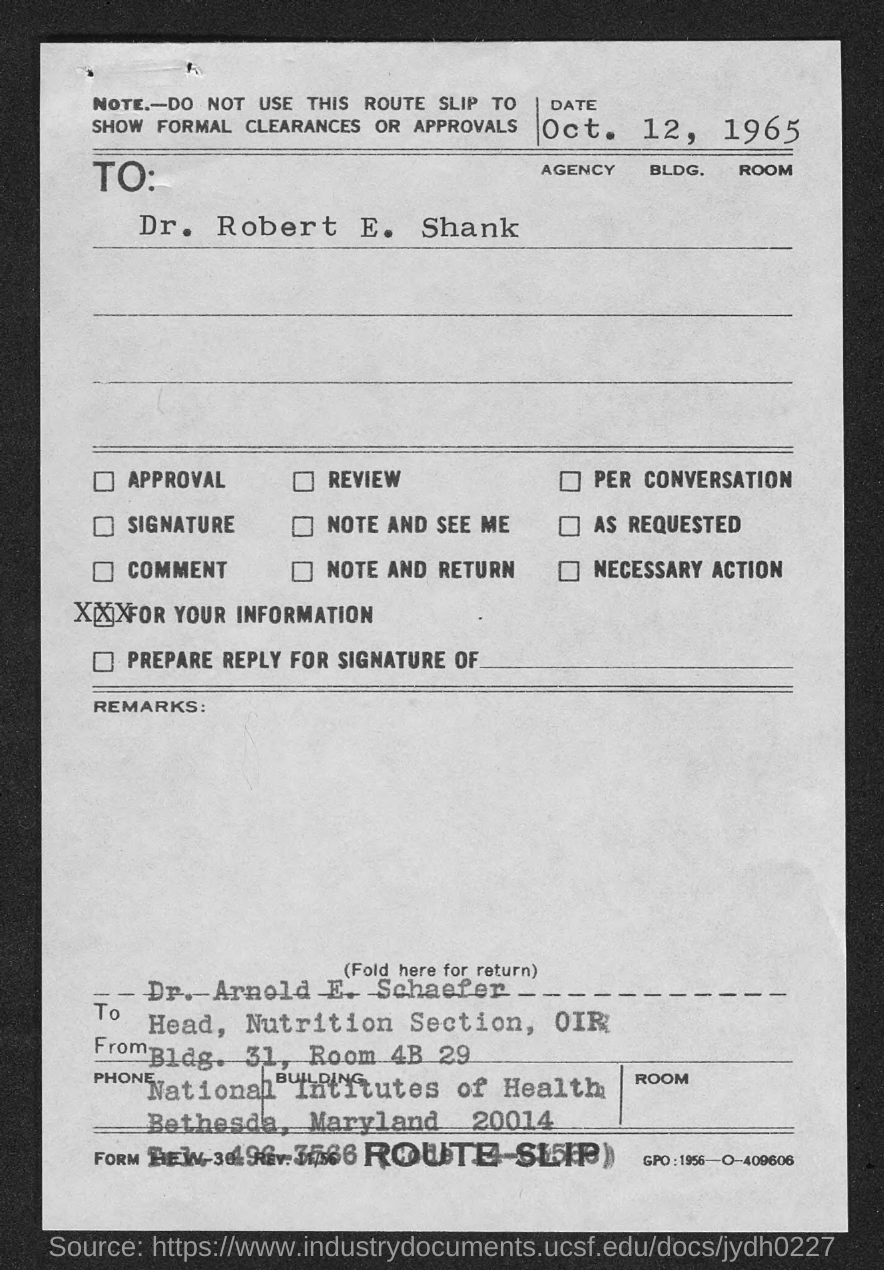What is the slip?
Make the answer very short. ROUTE SLIP. When is the slip dated?
Offer a terse response. Oct. 12, 1965. To whom is the slip addressed?
Give a very brief answer. Dr. Robert E. Shank. What is the code at the bottom right corner of the page?
Provide a short and direct response. GPO: 1956-O-409606. 